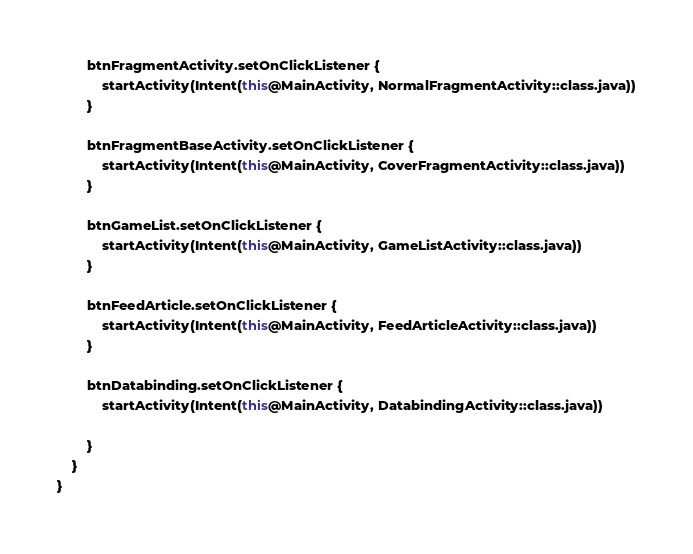<code> <loc_0><loc_0><loc_500><loc_500><_Kotlin_>        btnFragmentActivity.setOnClickListener {
            startActivity(Intent(this@MainActivity, NormalFragmentActivity::class.java))
        }

        btnFragmentBaseActivity.setOnClickListener {
            startActivity(Intent(this@MainActivity, CoverFragmentActivity::class.java))
        }

        btnGameList.setOnClickListener {
            startActivity(Intent(this@MainActivity, GameListActivity::class.java))
        }

        btnFeedArticle.setOnClickListener {
            startActivity(Intent(this@MainActivity, FeedArticleActivity::class.java))
        }

        btnDatabinding.setOnClickListener {
            startActivity(Intent(this@MainActivity, DatabindingActivity::class.java))

        }
    }
}
</code> 